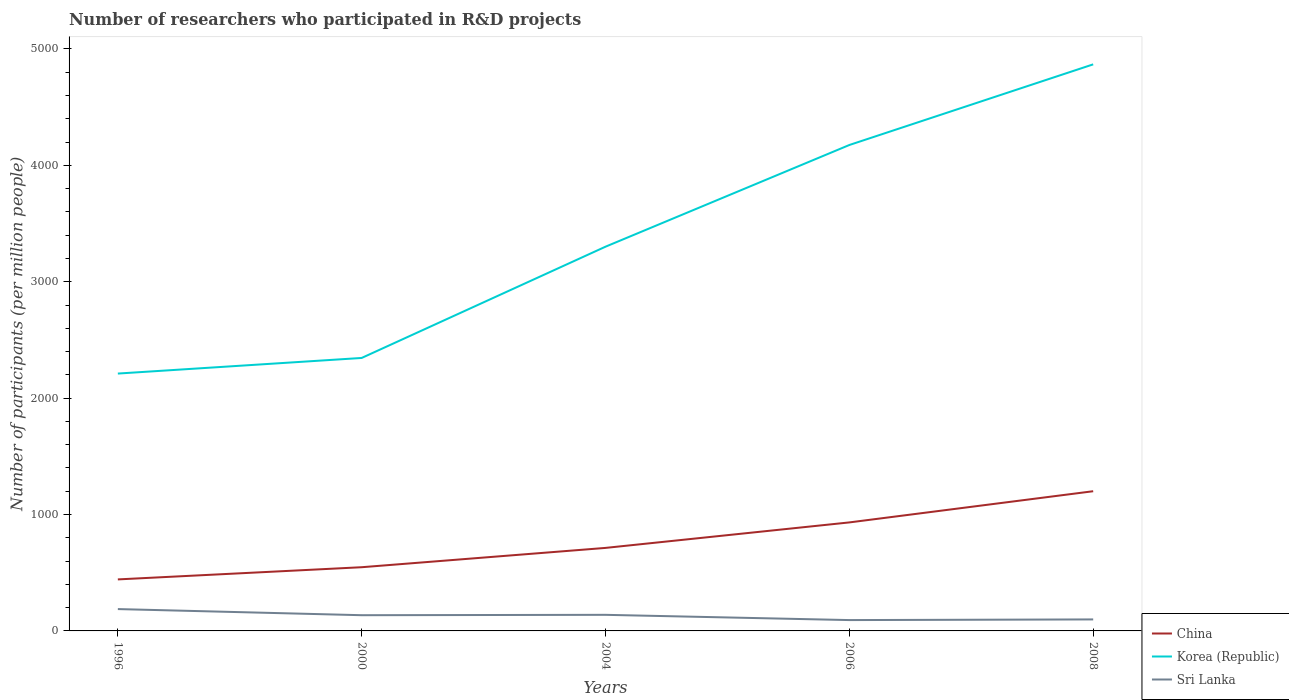How many different coloured lines are there?
Provide a succinct answer. 3. Does the line corresponding to Sri Lanka intersect with the line corresponding to Korea (Republic)?
Your response must be concise. No. Across all years, what is the maximum number of researchers who participated in R&D projects in China?
Give a very brief answer. 442.57. In which year was the number of researchers who participated in R&D projects in Sri Lanka maximum?
Your response must be concise. 2006. What is the total number of researchers who participated in R&D projects in Sri Lanka in the graph?
Make the answer very short. -3.21. What is the difference between the highest and the second highest number of researchers who participated in R&D projects in Sri Lanka?
Give a very brief answer. 94.49. What is the difference between the highest and the lowest number of researchers who participated in R&D projects in China?
Offer a terse response. 2. How many lines are there?
Make the answer very short. 3. How many years are there in the graph?
Your response must be concise. 5. What is the difference between two consecutive major ticks on the Y-axis?
Ensure brevity in your answer.  1000. Are the values on the major ticks of Y-axis written in scientific E-notation?
Provide a short and direct response. No. Does the graph contain grids?
Provide a succinct answer. No. Where does the legend appear in the graph?
Give a very brief answer. Bottom right. What is the title of the graph?
Your answer should be compact. Number of researchers who participated in R&D projects. Does "United Kingdom" appear as one of the legend labels in the graph?
Provide a succinct answer. No. What is the label or title of the X-axis?
Offer a terse response. Years. What is the label or title of the Y-axis?
Provide a short and direct response. Number of participants (per million people). What is the Number of participants (per million people) in China in 1996?
Your answer should be compact. 442.57. What is the Number of participants (per million people) of Korea (Republic) in 1996?
Make the answer very short. 2211.23. What is the Number of participants (per million people) of Sri Lanka in 1996?
Ensure brevity in your answer.  187.66. What is the Number of participants (per million people) of China in 2000?
Your answer should be compact. 547.3. What is the Number of participants (per million people) of Korea (Republic) in 2000?
Your answer should be compact. 2345.35. What is the Number of participants (per million people) of Sri Lanka in 2000?
Give a very brief answer. 135.06. What is the Number of participants (per million people) of China in 2004?
Your response must be concise. 713.28. What is the Number of participants (per million people) of Korea (Republic) in 2004?
Keep it short and to the point. 3301.31. What is the Number of participants (per million people) of Sri Lanka in 2004?
Your answer should be very brief. 138.28. What is the Number of participants (per million people) in China in 2006?
Your answer should be compact. 932.31. What is the Number of participants (per million people) in Korea (Republic) in 2006?
Ensure brevity in your answer.  4175.01. What is the Number of participants (per million people) in Sri Lanka in 2006?
Offer a very short reply. 93.18. What is the Number of participants (per million people) of China in 2008?
Offer a terse response. 1200.29. What is the Number of participants (per million people) of Korea (Republic) in 2008?
Provide a succinct answer. 4867.81. What is the Number of participants (per million people) in Sri Lanka in 2008?
Your response must be concise. 98.85. Across all years, what is the maximum Number of participants (per million people) of China?
Give a very brief answer. 1200.29. Across all years, what is the maximum Number of participants (per million people) in Korea (Republic)?
Provide a succinct answer. 4867.81. Across all years, what is the maximum Number of participants (per million people) of Sri Lanka?
Provide a short and direct response. 187.66. Across all years, what is the minimum Number of participants (per million people) in China?
Keep it short and to the point. 442.57. Across all years, what is the minimum Number of participants (per million people) in Korea (Republic)?
Your answer should be very brief. 2211.23. Across all years, what is the minimum Number of participants (per million people) in Sri Lanka?
Keep it short and to the point. 93.18. What is the total Number of participants (per million people) in China in the graph?
Your answer should be compact. 3835.76. What is the total Number of participants (per million people) in Korea (Republic) in the graph?
Provide a succinct answer. 1.69e+04. What is the total Number of participants (per million people) of Sri Lanka in the graph?
Your answer should be very brief. 653.03. What is the difference between the Number of participants (per million people) of China in 1996 and that in 2000?
Your answer should be very brief. -104.74. What is the difference between the Number of participants (per million people) in Korea (Republic) in 1996 and that in 2000?
Keep it short and to the point. -134.13. What is the difference between the Number of participants (per million people) of Sri Lanka in 1996 and that in 2000?
Provide a succinct answer. 52.6. What is the difference between the Number of participants (per million people) in China in 1996 and that in 2004?
Keep it short and to the point. -270.72. What is the difference between the Number of participants (per million people) of Korea (Republic) in 1996 and that in 2004?
Your answer should be compact. -1090.09. What is the difference between the Number of participants (per million people) in Sri Lanka in 1996 and that in 2004?
Ensure brevity in your answer.  49.39. What is the difference between the Number of participants (per million people) in China in 1996 and that in 2006?
Your answer should be compact. -489.75. What is the difference between the Number of participants (per million people) of Korea (Republic) in 1996 and that in 2006?
Make the answer very short. -1963.79. What is the difference between the Number of participants (per million people) in Sri Lanka in 1996 and that in 2006?
Give a very brief answer. 94.49. What is the difference between the Number of participants (per million people) in China in 1996 and that in 2008?
Your answer should be compact. -757.73. What is the difference between the Number of participants (per million people) of Korea (Republic) in 1996 and that in 2008?
Offer a terse response. -2656.59. What is the difference between the Number of participants (per million people) of Sri Lanka in 1996 and that in 2008?
Offer a terse response. 88.81. What is the difference between the Number of participants (per million people) in China in 2000 and that in 2004?
Ensure brevity in your answer.  -165.98. What is the difference between the Number of participants (per million people) of Korea (Republic) in 2000 and that in 2004?
Ensure brevity in your answer.  -955.96. What is the difference between the Number of participants (per million people) in Sri Lanka in 2000 and that in 2004?
Provide a succinct answer. -3.21. What is the difference between the Number of participants (per million people) of China in 2000 and that in 2006?
Your response must be concise. -385.01. What is the difference between the Number of participants (per million people) in Korea (Republic) in 2000 and that in 2006?
Offer a terse response. -1829.66. What is the difference between the Number of participants (per million people) in Sri Lanka in 2000 and that in 2006?
Your answer should be very brief. 41.89. What is the difference between the Number of participants (per million people) in China in 2000 and that in 2008?
Your answer should be very brief. -652.99. What is the difference between the Number of participants (per million people) in Korea (Republic) in 2000 and that in 2008?
Your answer should be compact. -2522.46. What is the difference between the Number of participants (per million people) in Sri Lanka in 2000 and that in 2008?
Your answer should be compact. 36.21. What is the difference between the Number of participants (per million people) in China in 2004 and that in 2006?
Provide a succinct answer. -219.03. What is the difference between the Number of participants (per million people) of Korea (Republic) in 2004 and that in 2006?
Offer a terse response. -873.7. What is the difference between the Number of participants (per million people) of Sri Lanka in 2004 and that in 2006?
Provide a succinct answer. 45.1. What is the difference between the Number of participants (per million people) in China in 2004 and that in 2008?
Give a very brief answer. -487.01. What is the difference between the Number of participants (per million people) of Korea (Republic) in 2004 and that in 2008?
Keep it short and to the point. -1566.5. What is the difference between the Number of participants (per million people) of Sri Lanka in 2004 and that in 2008?
Give a very brief answer. 39.43. What is the difference between the Number of participants (per million people) of China in 2006 and that in 2008?
Your response must be concise. -267.98. What is the difference between the Number of participants (per million people) in Korea (Republic) in 2006 and that in 2008?
Offer a very short reply. -692.8. What is the difference between the Number of participants (per million people) of Sri Lanka in 2006 and that in 2008?
Offer a terse response. -5.67. What is the difference between the Number of participants (per million people) in China in 1996 and the Number of participants (per million people) in Korea (Republic) in 2000?
Provide a succinct answer. -1902.79. What is the difference between the Number of participants (per million people) in China in 1996 and the Number of participants (per million people) in Sri Lanka in 2000?
Provide a succinct answer. 307.5. What is the difference between the Number of participants (per million people) in Korea (Republic) in 1996 and the Number of participants (per million people) in Sri Lanka in 2000?
Offer a terse response. 2076.16. What is the difference between the Number of participants (per million people) of China in 1996 and the Number of participants (per million people) of Korea (Republic) in 2004?
Your response must be concise. -2858.75. What is the difference between the Number of participants (per million people) in China in 1996 and the Number of participants (per million people) in Sri Lanka in 2004?
Ensure brevity in your answer.  304.29. What is the difference between the Number of participants (per million people) of Korea (Republic) in 1996 and the Number of participants (per million people) of Sri Lanka in 2004?
Your answer should be compact. 2072.95. What is the difference between the Number of participants (per million people) in China in 1996 and the Number of participants (per million people) in Korea (Republic) in 2006?
Your response must be concise. -3732.45. What is the difference between the Number of participants (per million people) of China in 1996 and the Number of participants (per million people) of Sri Lanka in 2006?
Provide a short and direct response. 349.39. What is the difference between the Number of participants (per million people) in Korea (Republic) in 1996 and the Number of participants (per million people) in Sri Lanka in 2006?
Provide a succinct answer. 2118.05. What is the difference between the Number of participants (per million people) of China in 1996 and the Number of participants (per million people) of Korea (Republic) in 2008?
Make the answer very short. -4425.25. What is the difference between the Number of participants (per million people) of China in 1996 and the Number of participants (per million people) of Sri Lanka in 2008?
Your response must be concise. 343.72. What is the difference between the Number of participants (per million people) in Korea (Republic) in 1996 and the Number of participants (per million people) in Sri Lanka in 2008?
Your response must be concise. 2112.38. What is the difference between the Number of participants (per million people) of China in 2000 and the Number of participants (per million people) of Korea (Republic) in 2004?
Your response must be concise. -2754.01. What is the difference between the Number of participants (per million people) in China in 2000 and the Number of participants (per million people) in Sri Lanka in 2004?
Provide a short and direct response. 409.03. What is the difference between the Number of participants (per million people) of Korea (Republic) in 2000 and the Number of participants (per million people) of Sri Lanka in 2004?
Make the answer very short. 2207.08. What is the difference between the Number of participants (per million people) in China in 2000 and the Number of participants (per million people) in Korea (Republic) in 2006?
Keep it short and to the point. -3627.71. What is the difference between the Number of participants (per million people) of China in 2000 and the Number of participants (per million people) of Sri Lanka in 2006?
Ensure brevity in your answer.  454.13. What is the difference between the Number of participants (per million people) in Korea (Republic) in 2000 and the Number of participants (per million people) in Sri Lanka in 2006?
Make the answer very short. 2252.18. What is the difference between the Number of participants (per million people) in China in 2000 and the Number of participants (per million people) in Korea (Republic) in 2008?
Your answer should be very brief. -4320.51. What is the difference between the Number of participants (per million people) of China in 2000 and the Number of participants (per million people) of Sri Lanka in 2008?
Provide a succinct answer. 448.45. What is the difference between the Number of participants (per million people) in Korea (Republic) in 2000 and the Number of participants (per million people) in Sri Lanka in 2008?
Keep it short and to the point. 2246.5. What is the difference between the Number of participants (per million people) in China in 2004 and the Number of participants (per million people) in Korea (Republic) in 2006?
Your answer should be compact. -3461.73. What is the difference between the Number of participants (per million people) in China in 2004 and the Number of participants (per million people) in Sri Lanka in 2006?
Make the answer very short. 620.11. What is the difference between the Number of participants (per million people) of Korea (Republic) in 2004 and the Number of participants (per million people) of Sri Lanka in 2006?
Ensure brevity in your answer.  3208.14. What is the difference between the Number of participants (per million people) of China in 2004 and the Number of participants (per million people) of Korea (Republic) in 2008?
Give a very brief answer. -4154.53. What is the difference between the Number of participants (per million people) of China in 2004 and the Number of participants (per million people) of Sri Lanka in 2008?
Provide a succinct answer. 614.44. What is the difference between the Number of participants (per million people) of Korea (Republic) in 2004 and the Number of participants (per million people) of Sri Lanka in 2008?
Ensure brevity in your answer.  3202.47. What is the difference between the Number of participants (per million people) of China in 2006 and the Number of participants (per million people) of Korea (Republic) in 2008?
Offer a very short reply. -3935.5. What is the difference between the Number of participants (per million people) in China in 2006 and the Number of participants (per million people) in Sri Lanka in 2008?
Your answer should be compact. 833.46. What is the difference between the Number of participants (per million people) of Korea (Republic) in 2006 and the Number of participants (per million people) of Sri Lanka in 2008?
Offer a very short reply. 4076.16. What is the average Number of participants (per million people) in China per year?
Offer a terse response. 767.15. What is the average Number of participants (per million people) of Korea (Republic) per year?
Keep it short and to the point. 3380.14. What is the average Number of participants (per million people) in Sri Lanka per year?
Your answer should be very brief. 130.61. In the year 1996, what is the difference between the Number of participants (per million people) in China and Number of participants (per million people) in Korea (Republic)?
Ensure brevity in your answer.  -1768.66. In the year 1996, what is the difference between the Number of participants (per million people) of China and Number of participants (per million people) of Sri Lanka?
Keep it short and to the point. 254.9. In the year 1996, what is the difference between the Number of participants (per million people) of Korea (Republic) and Number of participants (per million people) of Sri Lanka?
Offer a very short reply. 2023.57. In the year 2000, what is the difference between the Number of participants (per million people) of China and Number of participants (per million people) of Korea (Republic)?
Provide a succinct answer. -1798.05. In the year 2000, what is the difference between the Number of participants (per million people) of China and Number of participants (per million people) of Sri Lanka?
Your answer should be very brief. 412.24. In the year 2000, what is the difference between the Number of participants (per million people) in Korea (Republic) and Number of participants (per million people) in Sri Lanka?
Offer a very short reply. 2210.29. In the year 2004, what is the difference between the Number of participants (per million people) in China and Number of participants (per million people) in Korea (Republic)?
Keep it short and to the point. -2588.03. In the year 2004, what is the difference between the Number of participants (per million people) in China and Number of participants (per million people) in Sri Lanka?
Give a very brief answer. 575.01. In the year 2004, what is the difference between the Number of participants (per million people) in Korea (Republic) and Number of participants (per million people) in Sri Lanka?
Your response must be concise. 3163.04. In the year 2006, what is the difference between the Number of participants (per million people) in China and Number of participants (per million people) in Korea (Republic)?
Make the answer very short. -3242.7. In the year 2006, what is the difference between the Number of participants (per million people) in China and Number of participants (per million people) in Sri Lanka?
Keep it short and to the point. 839.14. In the year 2006, what is the difference between the Number of participants (per million people) of Korea (Republic) and Number of participants (per million people) of Sri Lanka?
Provide a succinct answer. 4081.84. In the year 2008, what is the difference between the Number of participants (per million people) in China and Number of participants (per million people) in Korea (Republic)?
Ensure brevity in your answer.  -3667.52. In the year 2008, what is the difference between the Number of participants (per million people) of China and Number of participants (per million people) of Sri Lanka?
Your answer should be very brief. 1101.45. In the year 2008, what is the difference between the Number of participants (per million people) in Korea (Republic) and Number of participants (per million people) in Sri Lanka?
Your answer should be compact. 4768.96. What is the ratio of the Number of participants (per million people) in China in 1996 to that in 2000?
Your answer should be very brief. 0.81. What is the ratio of the Number of participants (per million people) in Korea (Republic) in 1996 to that in 2000?
Offer a terse response. 0.94. What is the ratio of the Number of participants (per million people) in Sri Lanka in 1996 to that in 2000?
Your response must be concise. 1.39. What is the ratio of the Number of participants (per million people) in China in 1996 to that in 2004?
Offer a very short reply. 0.62. What is the ratio of the Number of participants (per million people) in Korea (Republic) in 1996 to that in 2004?
Give a very brief answer. 0.67. What is the ratio of the Number of participants (per million people) of Sri Lanka in 1996 to that in 2004?
Offer a very short reply. 1.36. What is the ratio of the Number of participants (per million people) in China in 1996 to that in 2006?
Make the answer very short. 0.47. What is the ratio of the Number of participants (per million people) in Korea (Republic) in 1996 to that in 2006?
Give a very brief answer. 0.53. What is the ratio of the Number of participants (per million people) of Sri Lanka in 1996 to that in 2006?
Offer a terse response. 2.01. What is the ratio of the Number of participants (per million people) of China in 1996 to that in 2008?
Provide a short and direct response. 0.37. What is the ratio of the Number of participants (per million people) of Korea (Republic) in 1996 to that in 2008?
Provide a succinct answer. 0.45. What is the ratio of the Number of participants (per million people) in Sri Lanka in 1996 to that in 2008?
Your response must be concise. 1.9. What is the ratio of the Number of participants (per million people) in China in 2000 to that in 2004?
Your response must be concise. 0.77. What is the ratio of the Number of participants (per million people) in Korea (Republic) in 2000 to that in 2004?
Provide a succinct answer. 0.71. What is the ratio of the Number of participants (per million people) of Sri Lanka in 2000 to that in 2004?
Keep it short and to the point. 0.98. What is the ratio of the Number of participants (per million people) of China in 2000 to that in 2006?
Offer a terse response. 0.59. What is the ratio of the Number of participants (per million people) in Korea (Republic) in 2000 to that in 2006?
Ensure brevity in your answer.  0.56. What is the ratio of the Number of participants (per million people) of Sri Lanka in 2000 to that in 2006?
Make the answer very short. 1.45. What is the ratio of the Number of participants (per million people) of China in 2000 to that in 2008?
Provide a short and direct response. 0.46. What is the ratio of the Number of participants (per million people) of Korea (Republic) in 2000 to that in 2008?
Ensure brevity in your answer.  0.48. What is the ratio of the Number of participants (per million people) in Sri Lanka in 2000 to that in 2008?
Offer a very short reply. 1.37. What is the ratio of the Number of participants (per million people) of China in 2004 to that in 2006?
Ensure brevity in your answer.  0.77. What is the ratio of the Number of participants (per million people) of Korea (Republic) in 2004 to that in 2006?
Offer a very short reply. 0.79. What is the ratio of the Number of participants (per million people) in Sri Lanka in 2004 to that in 2006?
Your answer should be compact. 1.48. What is the ratio of the Number of participants (per million people) of China in 2004 to that in 2008?
Provide a short and direct response. 0.59. What is the ratio of the Number of participants (per million people) of Korea (Republic) in 2004 to that in 2008?
Keep it short and to the point. 0.68. What is the ratio of the Number of participants (per million people) in Sri Lanka in 2004 to that in 2008?
Ensure brevity in your answer.  1.4. What is the ratio of the Number of participants (per million people) of China in 2006 to that in 2008?
Your response must be concise. 0.78. What is the ratio of the Number of participants (per million people) of Korea (Republic) in 2006 to that in 2008?
Your response must be concise. 0.86. What is the ratio of the Number of participants (per million people) in Sri Lanka in 2006 to that in 2008?
Offer a terse response. 0.94. What is the difference between the highest and the second highest Number of participants (per million people) in China?
Offer a very short reply. 267.98. What is the difference between the highest and the second highest Number of participants (per million people) of Korea (Republic)?
Give a very brief answer. 692.8. What is the difference between the highest and the second highest Number of participants (per million people) in Sri Lanka?
Keep it short and to the point. 49.39. What is the difference between the highest and the lowest Number of participants (per million people) of China?
Provide a succinct answer. 757.73. What is the difference between the highest and the lowest Number of participants (per million people) of Korea (Republic)?
Provide a short and direct response. 2656.59. What is the difference between the highest and the lowest Number of participants (per million people) in Sri Lanka?
Ensure brevity in your answer.  94.49. 